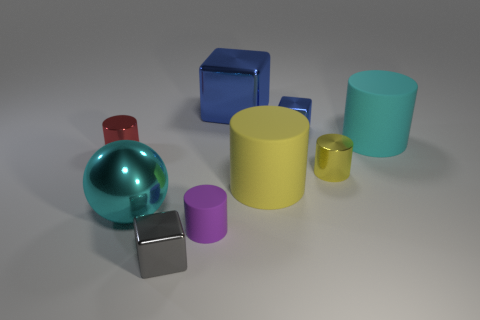Subtract all big cubes. How many cubes are left? 2 Subtract all cyan spheres. How many blue cubes are left? 2 Subtract 3 cylinders. How many cylinders are left? 2 Subtract all purple cylinders. How many cylinders are left? 4 Subtract all balls. How many objects are left? 8 Subtract all green cylinders. Subtract all purple spheres. How many cylinders are left? 5 Subtract all big yellow cylinders. Subtract all shiny spheres. How many objects are left? 7 Add 2 gray objects. How many gray objects are left? 3 Add 4 cyan metal spheres. How many cyan metal spheres exist? 5 Subtract 1 purple cylinders. How many objects are left? 8 